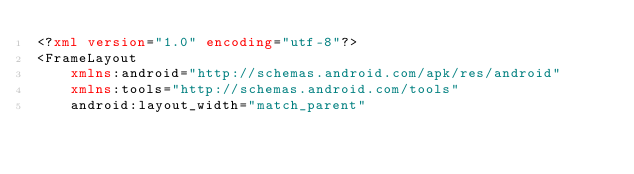<code> <loc_0><loc_0><loc_500><loc_500><_XML_><?xml version="1.0" encoding="utf-8"?>
<FrameLayout
    xmlns:android="http://schemas.android.com/apk/res/android"
    xmlns:tools="http://schemas.android.com/tools"
    android:layout_width="match_parent"</code> 